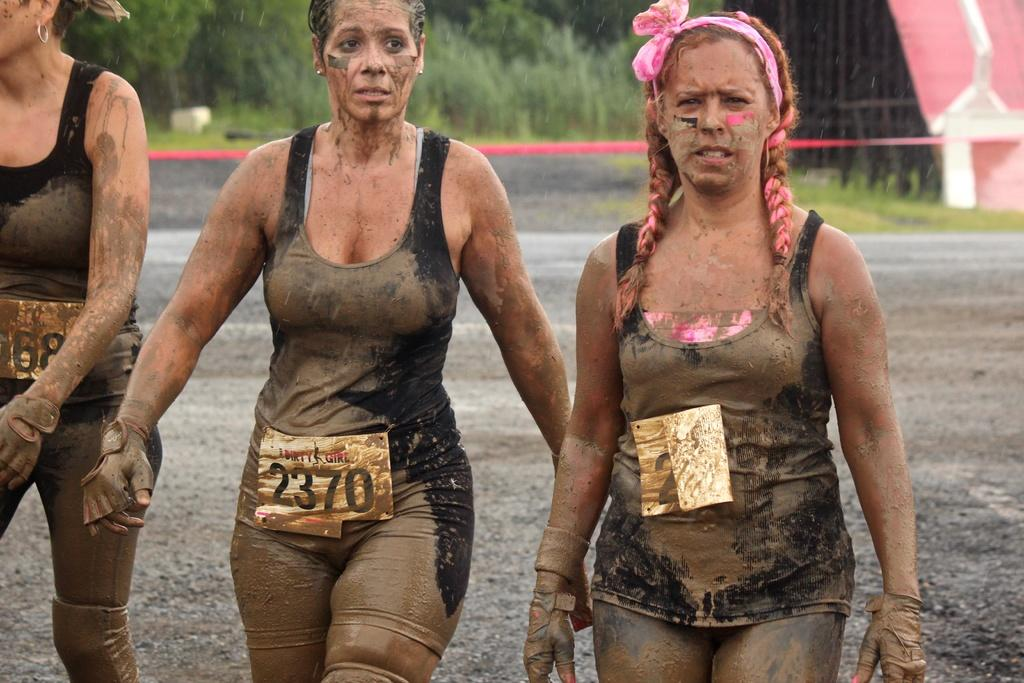How many people are in the image? There are three persons in the image. What are the persons wearing that can be seen in the image? The persons are wearing badges. What type of natural environment is visible in the background of the image? There is grass and plants in the background of the image. What type of architectural feature is present in the background of the image? Iron grills are present in the background of the image. What type of bottle can be seen in the hands of the lawyer in the image? There is no lawyer or bottle present in the image. Does the existence of the persons in the image prove the existence of extraterrestrial life? The presence of the persons in the image does not prove the existence of extraterrestrial life, as they are not related to that topic. 